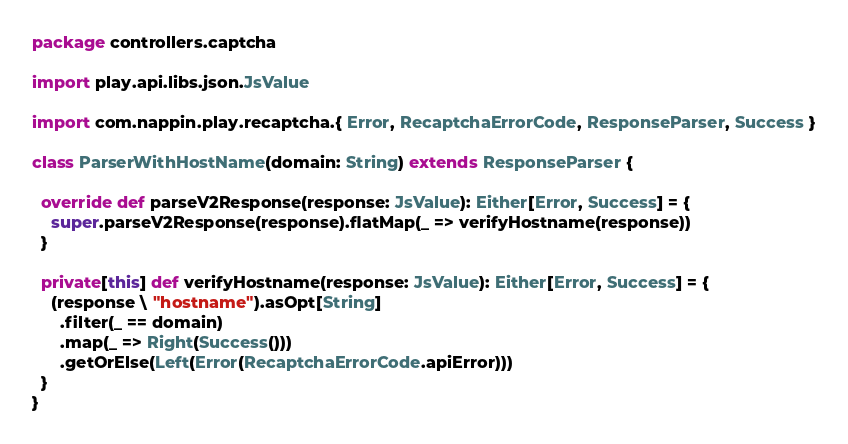Convert code to text. <code><loc_0><loc_0><loc_500><loc_500><_Scala_>package controllers.captcha

import play.api.libs.json.JsValue

import com.nappin.play.recaptcha.{ Error, RecaptchaErrorCode, ResponseParser, Success }

class ParserWithHostName(domain: String) extends ResponseParser {

  override def parseV2Response(response: JsValue): Either[Error, Success] = {
    super.parseV2Response(response).flatMap(_ => verifyHostname(response))
  }

  private[this] def verifyHostname(response: JsValue): Either[Error, Success] = {
    (response \ "hostname").asOpt[String]
      .filter(_ == domain)
      .map(_ => Right(Success()))
      .getOrElse(Left(Error(RecaptchaErrorCode.apiError)))
  }
}
</code> 